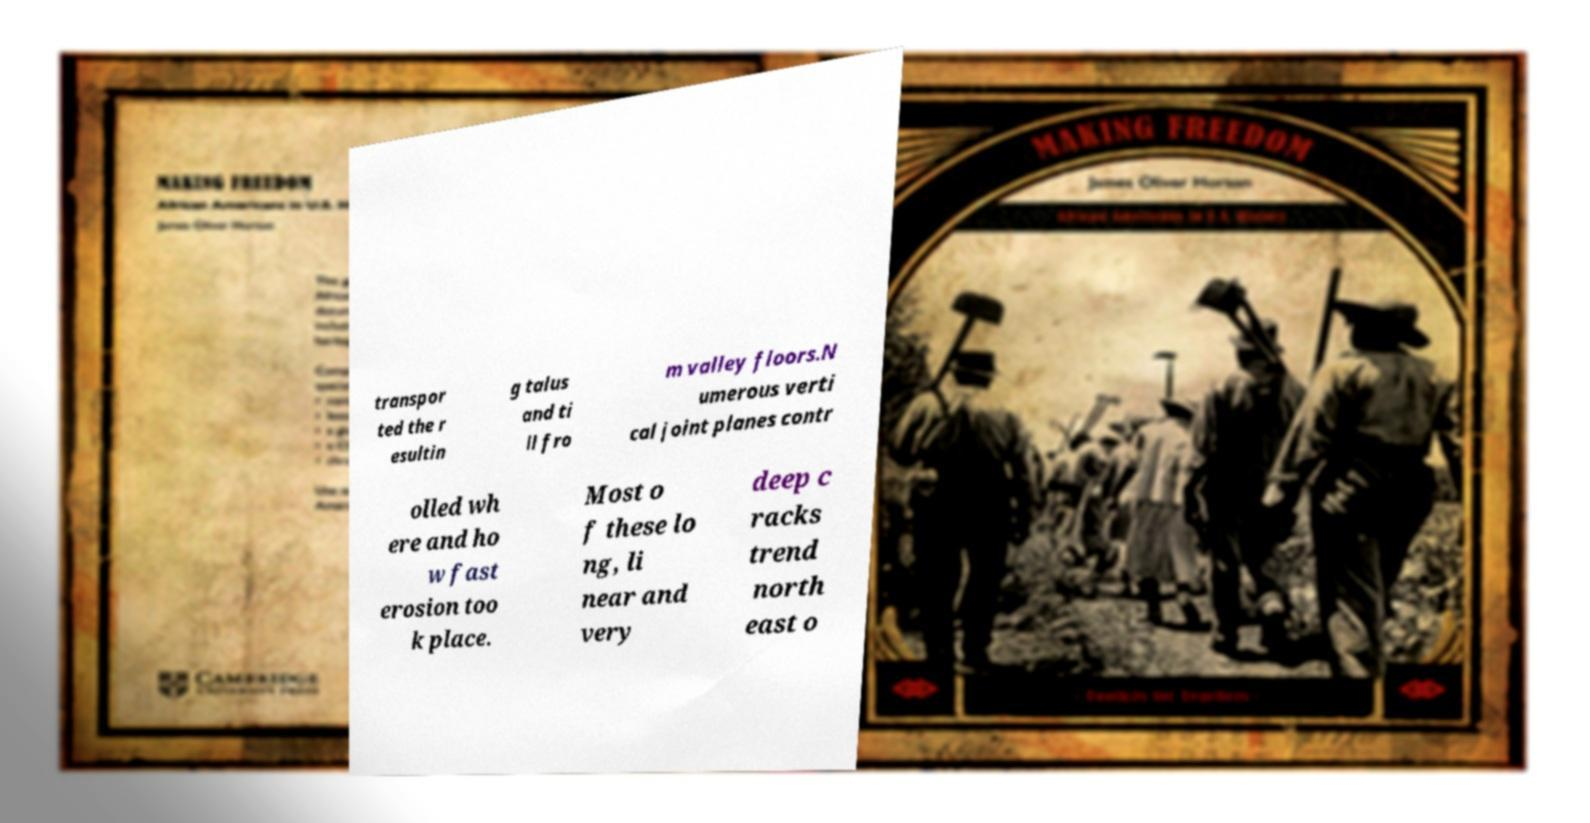I need the written content from this picture converted into text. Can you do that? transpor ted the r esultin g talus and ti ll fro m valley floors.N umerous verti cal joint planes contr olled wh ere and ho w fast erosion too k place. Most o f these lo ng, li near and very deep c racks trend north east o 